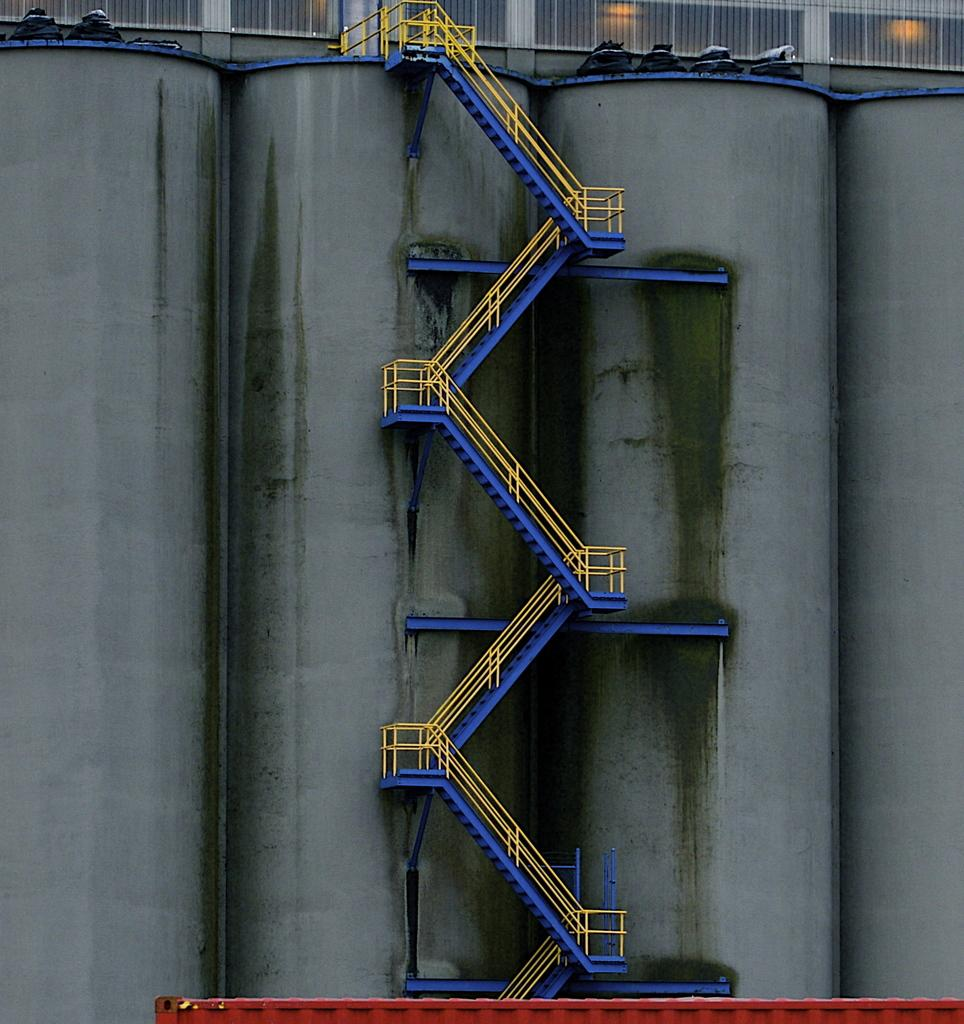What type of structure is present in the image? There is a staircase in the image. What else can be seen in the image? There is a wall and a fence in the image. Are there any sources of light in the image? Yes, there are lights in the image. Can you describe any unspecified objects in the image? Unfortunately, the provided facts do not specify the nature or appearance of these unspecified objects. Can you see any signs of a cave in the image? No, there is no mention of a cave in the provided facts about the image. 